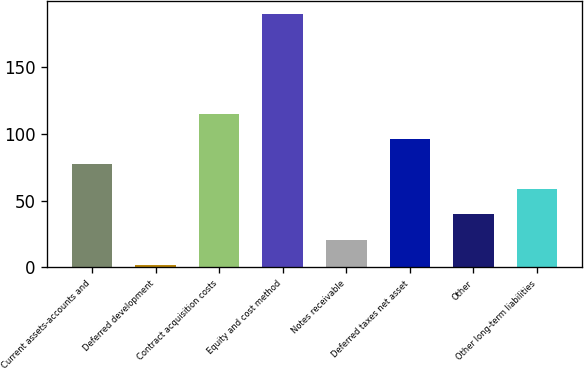<chart> <loc_0><loc_0><loc_500><loc_500><bar_chart><fcel>Current assets-accounts and<fcel>Deferred development<fcel>Contract acquisition costs<fcel>Equity and cost method<fcel>Notes receivable<fcel>Deferred taxes net asset<fcel>Other<fcel>Other long-term liabilities<nl><fcel>77.2<fcel>2<fcel>114.8<fcel>190<fcel>20.8<fcel>96<fcel>39.6<fcel>58.4<nl></chart> 